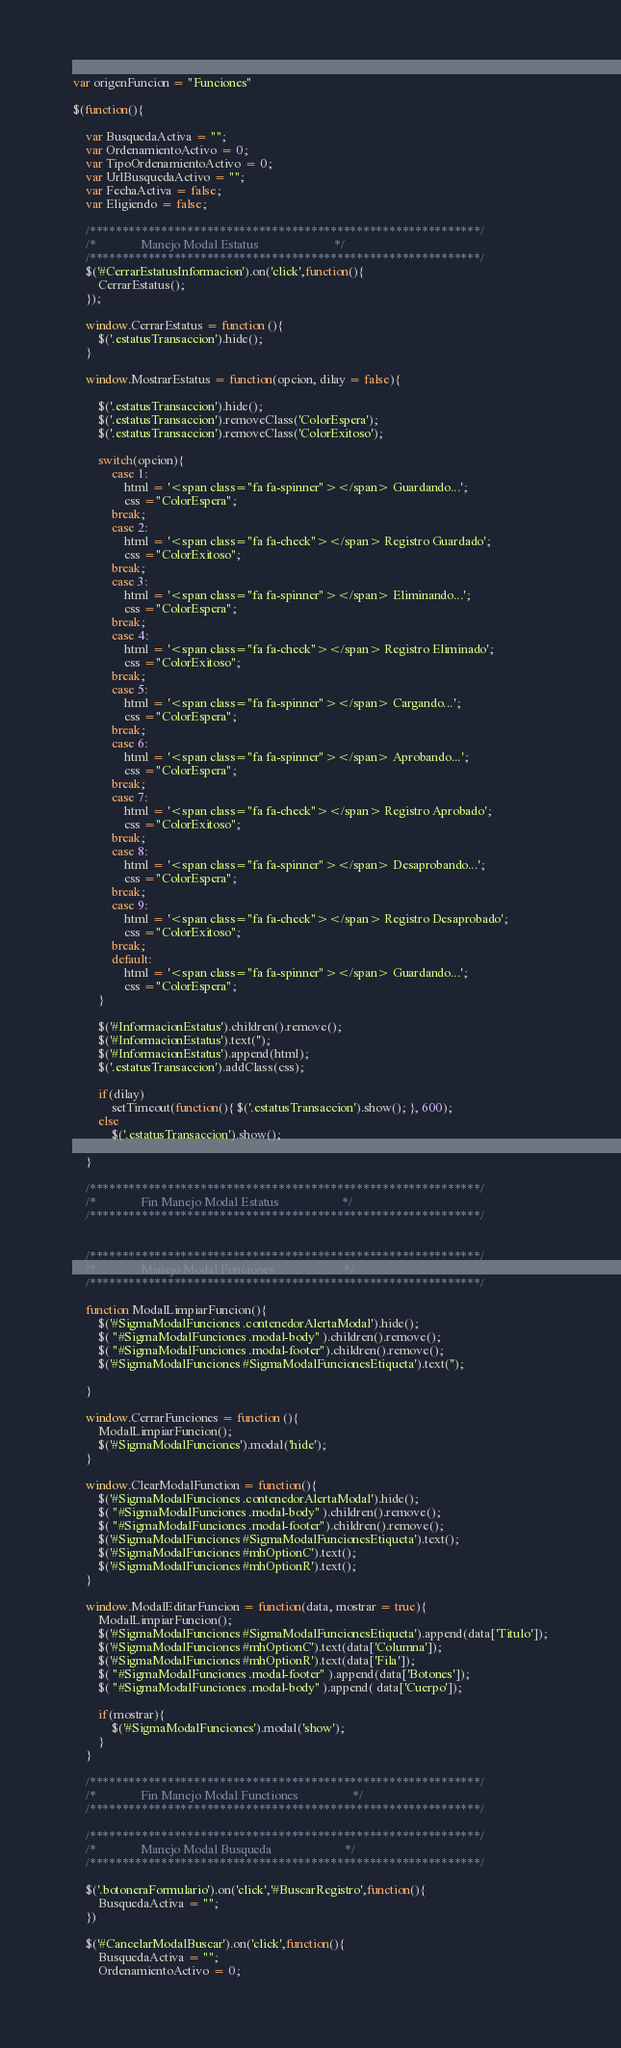<code> <loc_0><loc_0><loc_500><loc_500><_JavaScript_>var origenFuncion = "Funciones"

$(function(){

    var BusquedaActiva = "";
    var OrdenamientoActivo = 0;
    var TipoOrdenamientoActivo = 0;
    var UrlBusquedaActivo = "";
    var FechaActiva = false;
    var Eligiendo = false;

    /************************************************************/
    /*              Manejo Modal Estatus                        */
    /************************************************************/
    $('#CerrarEstatusInformacion').on('click',function(){
        CerrarEstatus();
    });

    window.CerrarEstatus = function (){
        $('.estatusTransaccion').hide();
    }

    window.MostrarEstatus = function(opcion, dilay = false){
        
        $('.estatusTransaccion').hide();
        $('.estatusTransaccion').removeClass('ColorEspera');
        $('.estatusTransaccion').removeClass('ColorExitoso');

        switch(opcion){
            case 1:
                html = '<span class="fa fa-spinner"></span> Guardando...';
                css ="ColorEspera";
            break;
            case 2:
                html = '<span class="fa fa-check"></span> Registro Guardado';
                css ="ColorExitoso";
            break;
            case 3:
                html = '<span class="fa fa-spinner"></span> Eliminando...';
                css ="ColorEspera";
            break;
            case 4:
                html = '<span class="fa fa-check"></span> Registro Eliminado';
                css ="ColorExitoso";
            break;
            case 5:
                html = '<span class="fa fa-spinner"></span> Cargando...';
                css ="ColorEspera";
            break;
            case 6:
                html = '<span class="fa fa-spinner"></span> Aprobando...';
                css ="ColorEspera";
            break;
            case 7:
                html = '<span class="fa fa-check"></span> Registro Aprobado';
                css ="ColorExitoso";
            break;
            case 8:
                html = '<span class="fa fa-spinner"></span> Desaprobando...';
                css ="ColorEspera";
            break;
            case 9:
                html = '<span class="fa fa-check"></span> Registro Desaprobado';
                css ="ColorExitoso";
            break;
            default:
                html = '<span class="fa fa-spinner"></span> Guardando...';
                css ="ColorEspera";
        }

        $('#InformacionEstatus').children().remove();
        $('#InformacionEstatus').text('');
        $('#InformacionEstatus').append(html);
        $('.estatusTransaccion').addClass(css);
        
        if(dilay)
            setTimeout(function(){ $('.estatusTransaccion').show(); }, 600);
        else
            $('.estatusTransaccion').show();
        
    }

    /************************************************************/
    /*              Fin Manejo Modal Estatus                    */
    /************************************************************/

    
    /************************************************************/
    /*              Manejo Modal Funciones                      */
    /************************************************************/

    function ModalLimpiarFuncion(){
        $('#SigmaModalFunciones .contenedorAlertaModal').hide();
        $( "#SigmaModalFunciones .modal-body" ).children().remove();
        $( "#SigmaModalFunciones .modal-footer").children().remove();
        $('#SigmaModalFunciones #SigmaModalFuncionesEtiqueta').text('');

    }

    window.CerrarFunciones = function (){
        ModalLimpiarFuncion();
        $('#SigmaModalFunciones').modal('hide');
    }
    
    window.ClearModalFunction = function(){
        $('#SigmaModalFunciones .contenedorAlertaModal').hide();
        $( "#SigmaModalFunciones .modal-body" ).children().remove();
        $( "#SigmaModalFunciones .modal-footer").children().remove();
        $('#SigmaModalFunciones #SigmaModalFuncionesEtiqueta').text();
        $('#SigmaModalFunciones #mhOptionC').text();
        $('#SigmaModalFunciones #mhOptionR').text();
    }

    window.ModalEditarFuncion = function(data, mostrar = true){
        ModalLimpiarFuncion();
        $('#SigmaModalFunciones #SigmaModalFuncionesEtiqueta').append(data['Titulo']);
        $('#SigmaModalFunciones #mhOptionC').text(data['Columna']);
        $('#SigmaModalFunciones #mhOptionR').text(data['Fila']);
        $( "#SigmaModalFunciones .modal-footer" ).append(data['Botones']);
        $( "#SigmaModalFunciones .modal-body" ).append( data['Cuerpo']);

        if(mostrar){
            $('#SigmaModalFunciones').modal('show');
        }
    }

    /************************************************************/
    /*              Fin Manejo Modal Functiones                 */
    /************************************************************/

    /************************************************************/
    /*              Manejo Modal Busqueda                       */
    /************************************************************/
    
    $('.botoneraFormulario').on('click','#BuscarRegistro',function(){
        BusquedaActiva = "";
    })

    $('#CancelarModalBuscar').on('click',function(){
        BusquedaActiva = "";
        OrdenamientoActivo = 0;</code> 